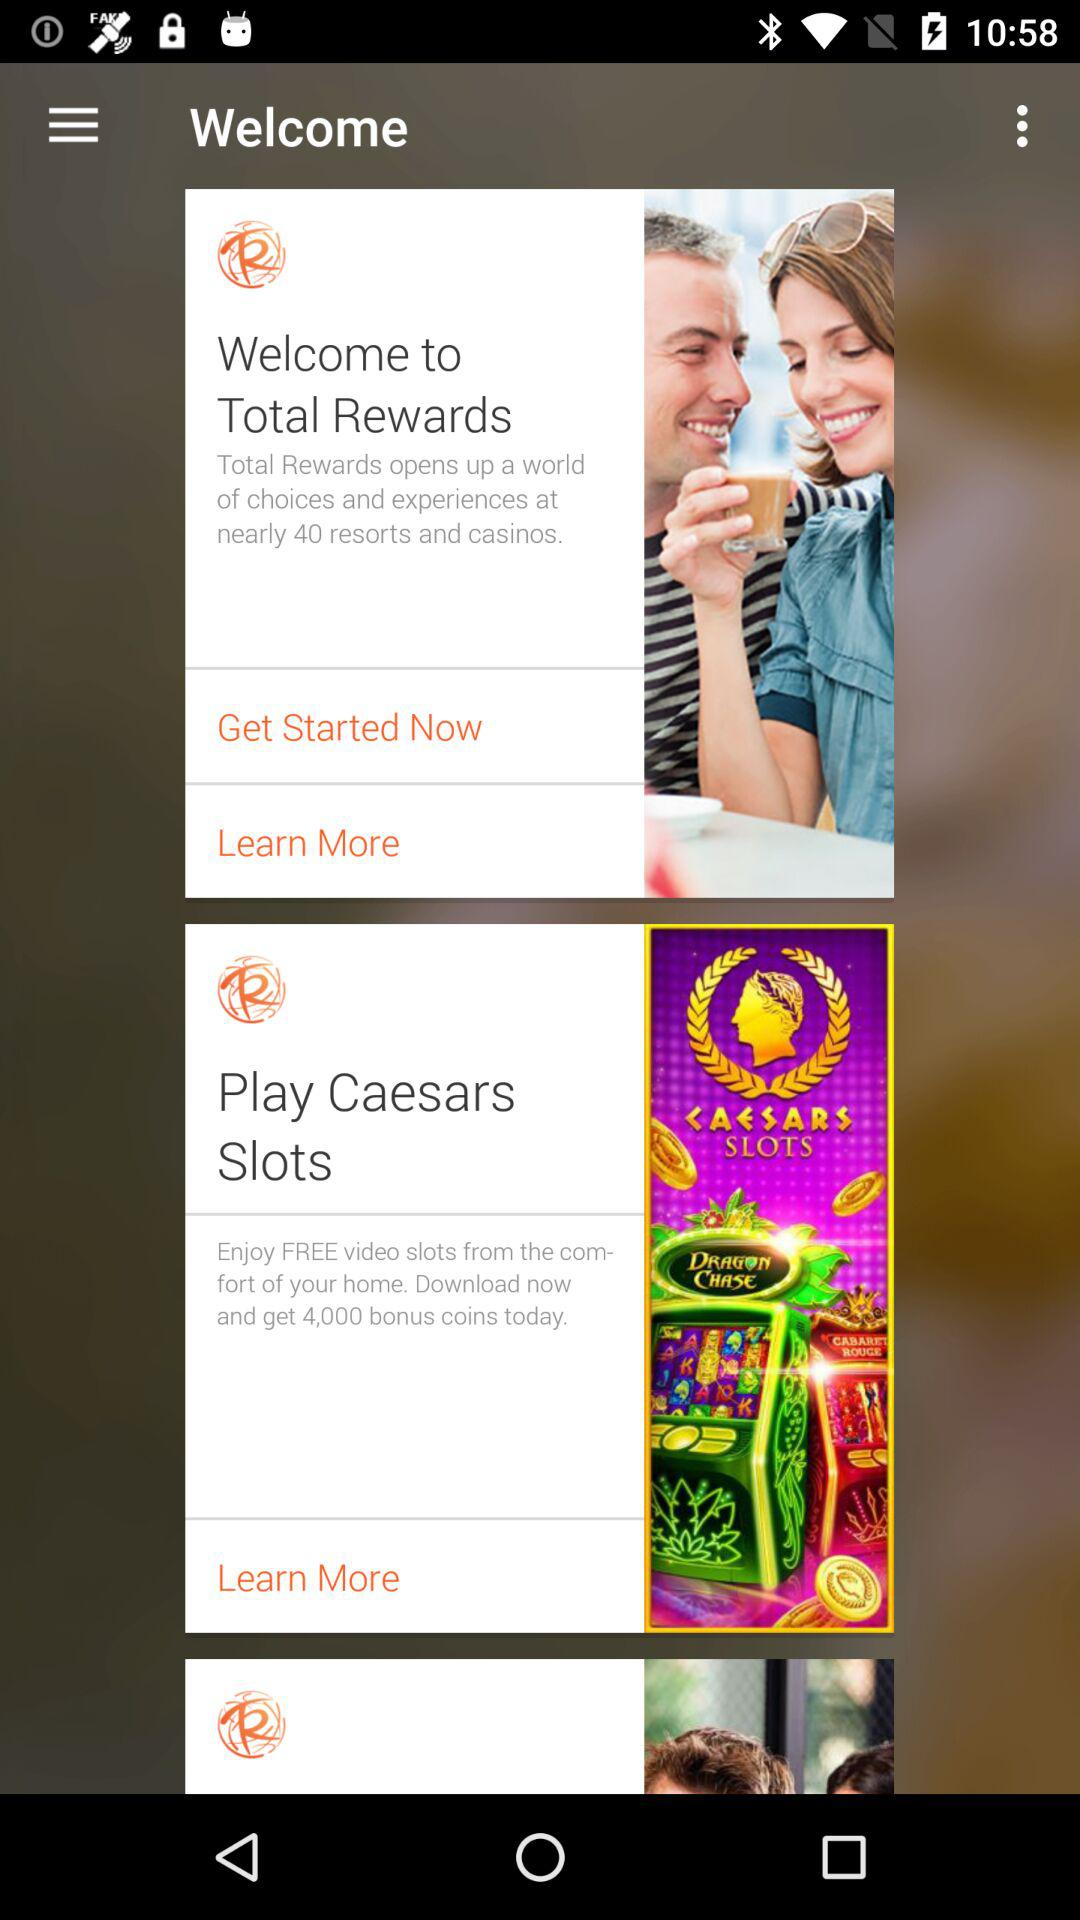Who is this application powered by?
When the provided information is insufficient, respond with <no answer>. <no answer> 